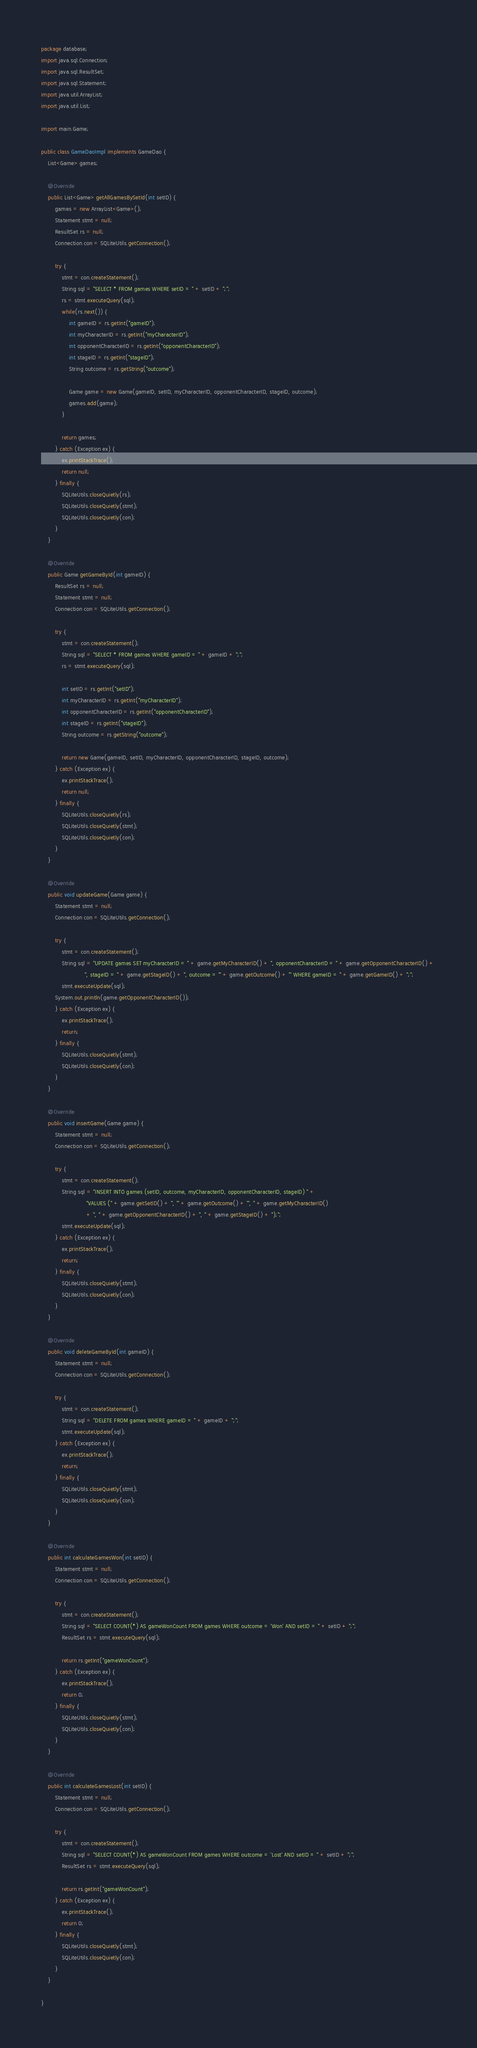<code> <loc_0><loc_0><loc_500><loc_500><_Java_>package database;
import java.sql.Connection;
import java.sql.ResultSet;
import java.sql.Statement;
import java.util.ArrayList;
import java.util.List;

import main.Game;

public class GameDaoImpl implements GameDao {
	List<Game> games;
	
	@Override
	public List<Game> getAllGamesBySetId(int setID) {
		games = new ArrayList<Game>();
		Statement stmt = null;
		ResultSet rs = null;
		Connection con = SQLiteUtils.getConnection();
		
		try {
			stmt = con.createStatement();
			String sql = "SELECT * FROM games WHERE setID = " + setID + ";"; 
			rs = stmt.executeQuery(sql);
			while(rs.next()) {
				int gameID = rs.getInt("gameID");
				int myCharacterID = rs.getInt("myCharacterID");
				int opponentCharacterID = rs.getInt("opponentCharacterID");
				int stageID = rs.getInt("stageID");
				String outcome = rs.getString("outcome");
				
				Game game = new Game(gameID, setID, myCharacterID, opponentCharacterID, stageID, outcome);
				games.add(game);
			}
			
			return games;
		} catch (Exception ex) {
 			ex.printStackTrace();
 			return null;
 		} finally {
 			SQLiteUtils.closeQuietly(rs);
 			SQLiteUtils.closeQuietly(stmt);
 			SQLiteUtils.closeQuietly(con);
 		}
	}

	@Override
	public Game getGameById(int gameID) {
		ResultSet rs = null;
		Statement stmt = null;
		Connection con = SQLiteUtils.getConnection();
		
		try {
			stmt = con.createStatement();
			String sql = "SELECT * FROM games WHERE gameID = " + gameID + ";";
	 		rs = stmt.executeQuery(sql);
	 		
	 		int setID = rs.getInt("setID");
	 		int myCharacterID = rs.getInt("myCharacterID");
	 		int opponentCharacterID = rs.getInt("opponentCharacterID");
	 		int stageID = rs.getInt("stageID");
	 		String outcome = rs.getString("outcome");

	 		return new Game(gameID, setID, myCharacterID, opponentCharacterID, stageID, outcome);
		} catch (Exception ex) {
 			ex.printStackTrace();
			return null;
 		} finally {
 			SQLiteUtils.closeQuietly(rs);
 			SQLiteUtils.closeQuietly(stmt);
 			SQLiteUtils.closeQuietly(con);
 		}
	}

	@Override
	public void updateGame(Game game) {
		Statement stmt = null;
		Connection con = SQLiteUtils.getConnection();
		
		try {
			stmt = con.createStatement();
	 		String sql = "UPDATE games SET myCharacterID = " + game.getMyCharacterID() + ", opponentCharacterID = " + game.getOpponentCharacterID() + 
	 					 ", stageID = " + game.getStageID() + ", outcome = '" + game.getOutcome() + "' WHERE gameID = " + game.getGameID() + ";";
	 		stmt.executeUpdate(sql);
		System.out.println(game.getOpponentCharacterID());
		} catch (Exception ex) {
 			ex.printStackTrace();
			return;
 		} finally {
 			SQLiteUtils.closeQuietly(stmt);
 			SQLiteUtils.closeQuietly(con);
 		}
	}

	@Override
	public void insertGame(Game game) {
		Statement stmt = null;
		Connection con = SQLiteUtils.getConnection();
		
		try {
			stmt = con.createStatement();
			String sql = "INSERT INTO games (setID, outcome, myCharacterID, opponentCharacterID, stageID) " +
						  "VALUES (" + game.getSetID() + ", '" + game.getOutcome() + "', " + game.getMyCharacterID()
						  + ", " + game.getOpponentCharacterID() + ", " + game.getStageID() + ");";
			stmt.executeUpdate(sql);
		} catch (Exception ex) {
 			ex.printStackTrace();
			return;
 		} finally {
 			SQLiteUtils.closeQuietly(stmt);
 			SQLiteUtils.closeQuietly(con);
 		}
	}

	@Override
	public void deleteGameById(int gameID) {
		Statement stmt = null;
		Connection con = SQLiteUtils.getConnection();
		
		try {
			stmt = con.createStatement();
			String sql = "DELETE FROM games WHERE gameID = " + gameID + ";";
	 		stmt.executeUpdate(sql);
		} catch (Exception ex) {
 			ex.printStackTrace();
			return;
 		} finally {
 			SQLiteUtils.closeQuietly(stmt);
 			SQLiteUtils.closeQuietly(con);
 		}
	}

	@Override
	public int calculateGamesWon(int setID) {
		Statement stmt = null;
		Connection con = SQLiteUtils.getConnection();
		
		try {
			stmt = con.createStatement();
			String sql = "SELECT COUNT(*) AS gameWonCount FROM games WHERE outcome = 'Won' AND setID = " + setID + ";";
			ResultSet rs = stmt.executeQuery(sql);		
			
			return rs.getInt("gameWonCount");
		} catch (Exception ex) {
 			ex.printStackTrace();
			return 0;
 		} finally {
 			SQLiteUtils.closeQuietly(stmt);
 			SQLiteUtils.closeQuietly(con);
 		}
	}

	@Override
	public int calculateGamesLost(int setID) {
		Statement stmt = null;
		Connection con = SQLiteUtils.getConnection();
		
		try {
			stmt = con.createStatement();
			String sql = "SELECT COUNT(*) AS gameWonCount FROM games WHERE outcome = 'Lost' AND setID = " + setID + ";";
			ResultSet rs = stmt.executeQuery(sql);		
			
			return rs.getInt("gameWonCount");
		} catch (Exception ex) {
 			ex.printStackTrace();
			return 0;
 		} finally {
 			SQLiteUtils.closeQuietly(stmt);
 			SQLiteUtils.closeQuietly(con);
 		}		
	}

}
</code> 